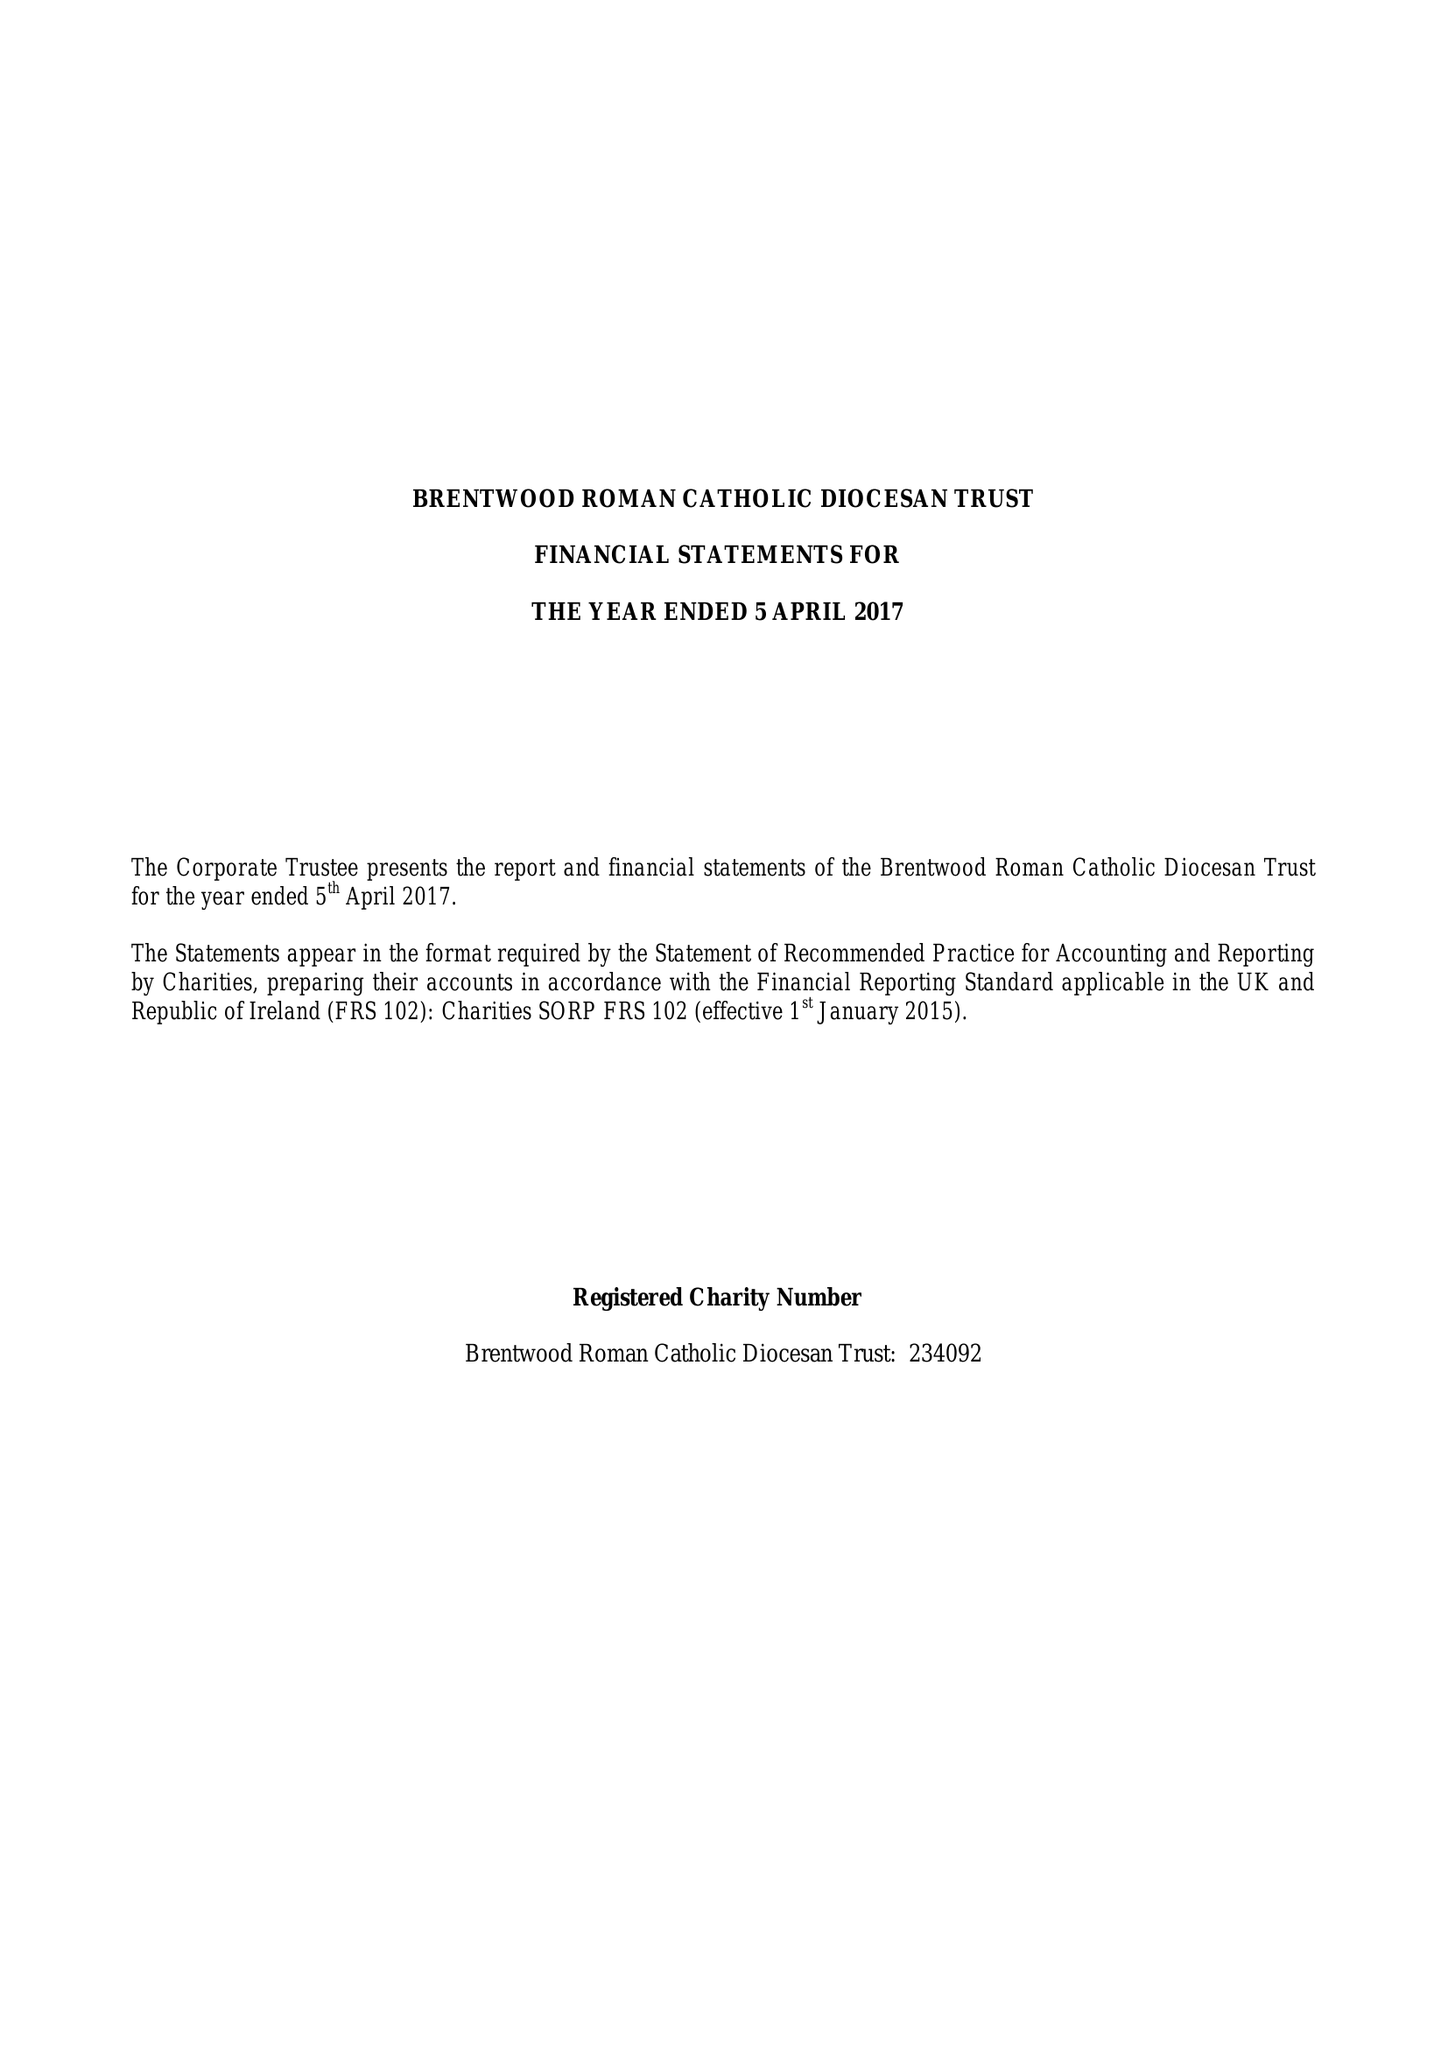What is the value for the report_date?
Answer the question using a single word or phrase. 2017-04-05 